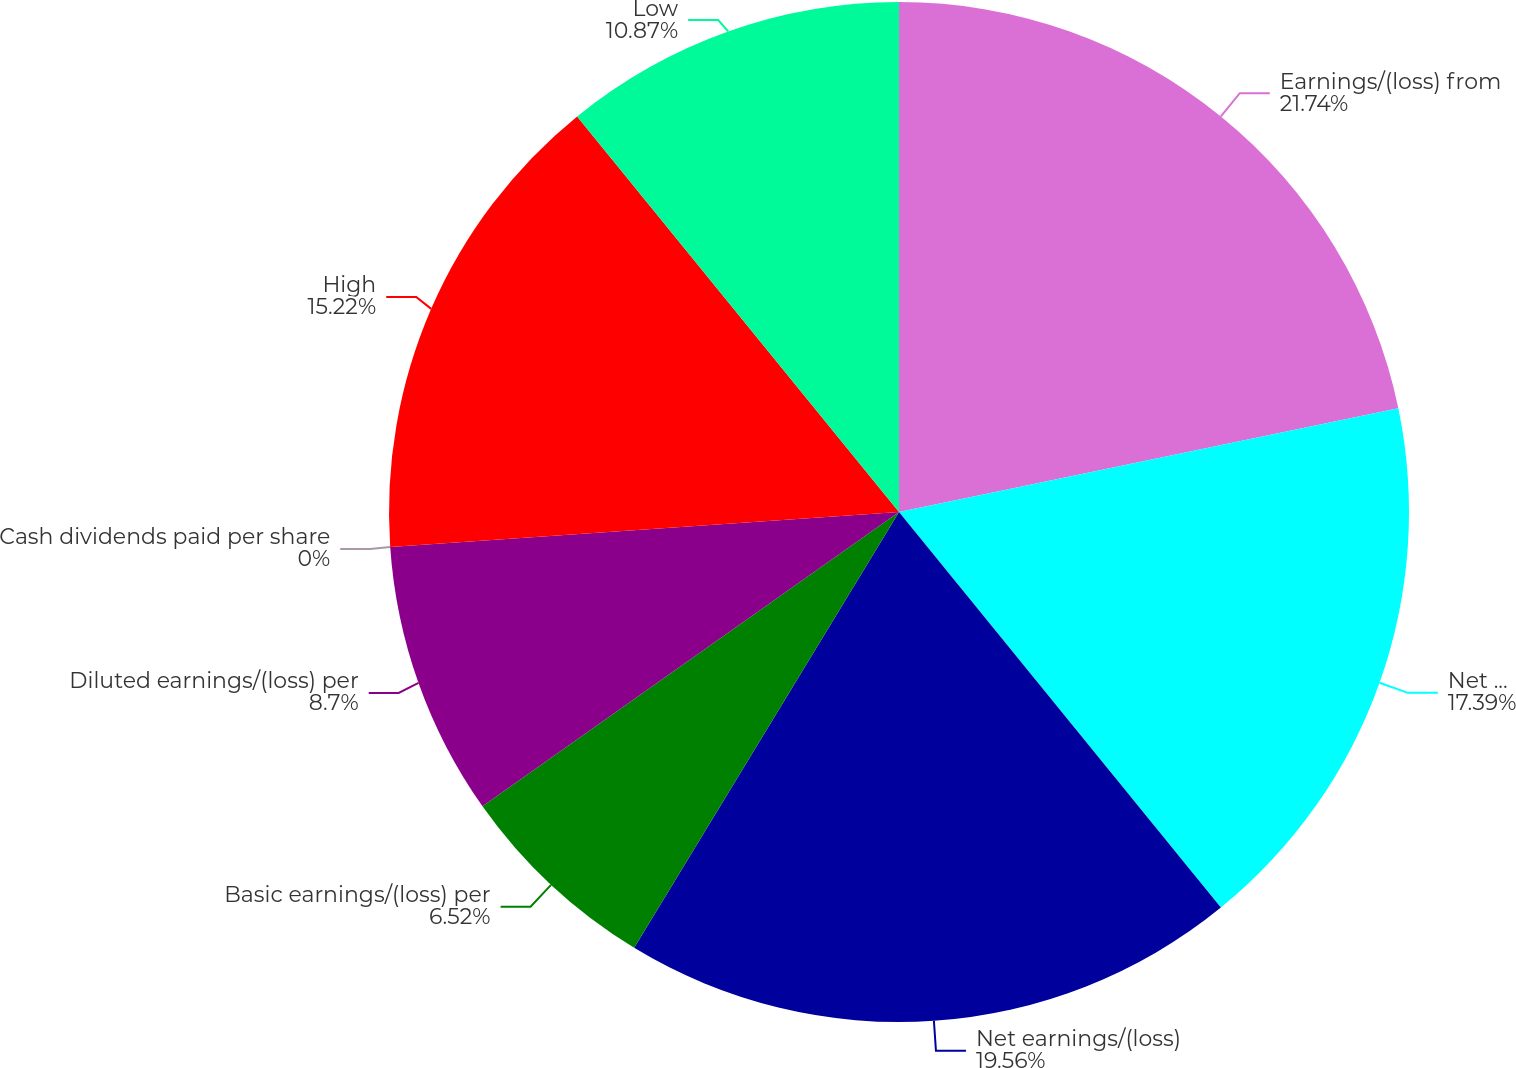Convert chart to OTSL. <chart><loc_0><loc_0><loc_500><loc_500><pie_chart><fcel>Earnings/(loss) from<fcel>Net earnings/(loss) from<fcel>Net earnings/(loss)<fcel>Basic earnings/(loss) per<fcel>Diluted earnings/(loss) per<fcel>Cash dividends paid per share<fcel>High<fcel>Low<nl><fcel>21.74%<fcel>17.39%<fcel>19.56%<fcel>6.52%<fcel>8.7%<fcel>0.0%<fcel>15.22%<fcel>10.87%<nl></chart> 